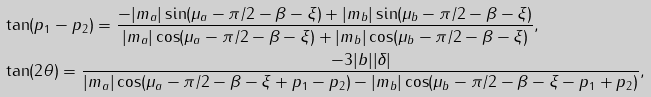Convert formula to latex. <formula><loc_0><loc_0><loc_500><loc_500>& \tan ( p _ { 1 } - p _ { 2 } ) = \frac { - | m _ { a } | \sin ( \mu _ { a } - \pi / 2 - \beta - \xi ) + | m _ { b } | \sin ( \mu _ { b } - \pi / 2 - \beta - \xi ) } { | m _ { a } | \cos ( \mu _ { a } - \pi / 2 - \beta - \xi ) + | m _ { b } | \cos ( \mu _ { b } - \pi / 2 - \beta - \xi ) } , \\ & \tan ( 2 \theta ) = \frac { - 3 | b | | \delta | } { | m _ { a } | \cos ( \mu _ { a } - \pi / 2 - \beta - \xi + p _ { 1 } - p _ { 2 } ) - | m _ { b } | \cos ( \mu _ { b } - \pi / 2 - \beta - \xi - p _ { 1 } + p _ { 2 } ) } ,</formula> 